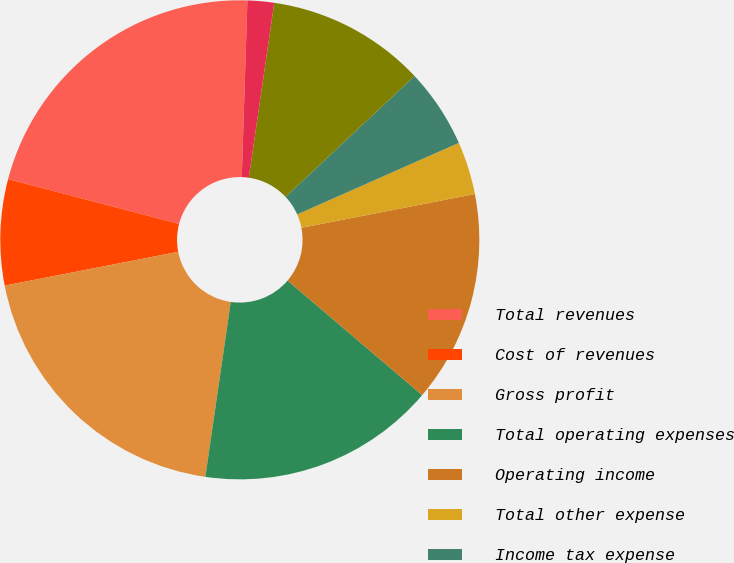Convert chart to OTSL. <chart><loc_0><loc_0><loc_500><loc_500><pie_chart><fcel>Total revenues<fcel>Cost of revenues<fcel>Gross profit<fcel>Total operating expenses<fcel>Operating income<fcel>Total other expense<fcel>Income tax expense<fcel>Net income<fcel>Net income applicable to<nl><fcel>21.43%<fcel>7.14%<fcel>19.64%<fcel>16.07%<fcel>14.29%<fcel>3.57%<fcel>5.36%<fcel>10.71%<fcel>1.79%<nl></chart> 